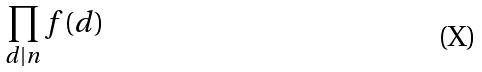Convert formula to latex. <formula><loc_0><loc_0><loc_500><loc_500>\prod _ { d | n } f ( d )</formula> 